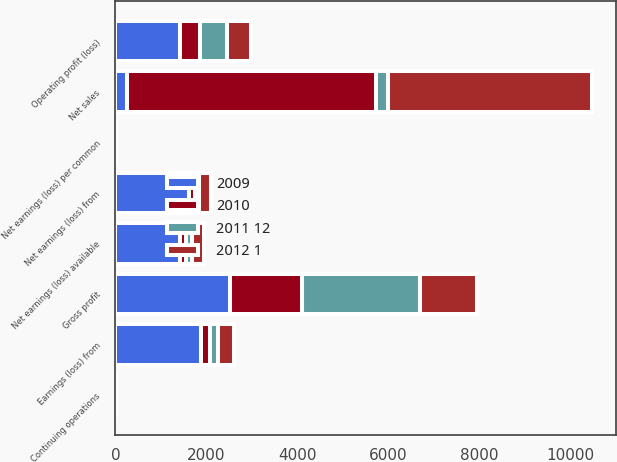<chart> <loc_0><loc_0><loc_500><loc_500><stacked_bar_chart><ecel><fcel>Net sales<fcel>Gross profit<fcel>Operating profit (loss)<fcel>Earnings (loss) from<fcel>Net earnings (loss) from<fcel>Net earnings (loss) available<fcel>Continuing operations<fcel>Net earnings (loss) per common<nl><fcel>2011 12<fcel>255.9<fcel>2587.5<fcel>602.1<fcel>177.7<fcel>93.7<fcel>124.2<fcel>0.48<fcel>0.64<nl><fcel>2009<fcel>255.9<fcel>2522.3<fcel>1427.7<fcel>1882.6<fcel>1617.9<fcel>1410.3<fcel>8.39<fcel>7.31<nl><fcel>2010<fcel>5467.3<fcel>1580.6<fcel>420.8<fcel>189.4<fcel>132.7<fcel>149.1<fcel>0.79<fcel>0.89<nl><fcel>2012 1<fcel>4490.1<fcel>1252.8<fcel>535<fcel>343.4<fcel>255.9<fcel>255.9<fcel>1.61<fcel>1.61<nl></chart> 